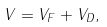Convert formula to latex. <formula><loc_0><loc_0><loc_500><loc_500>V = V _ { F } + V _ { D } ,</formula> 